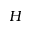<formula> <loc_0><loc_0><loc_500><loc_500>H</formula> 